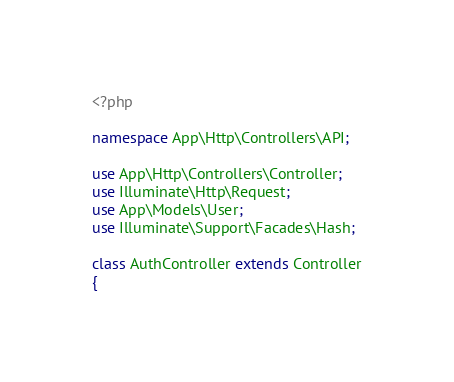<code> <loc_0><loc_0><loc_500><loc_500><_PHP_><?php

namespace App\Http\Controllers\API;

use App\Http\Controllers\Controller;
use Illuminate\Http\Request;
use App\Models\User;
use Illuminate\Support\Facades\Hash;

class AuthController extends Controller
{</code> 